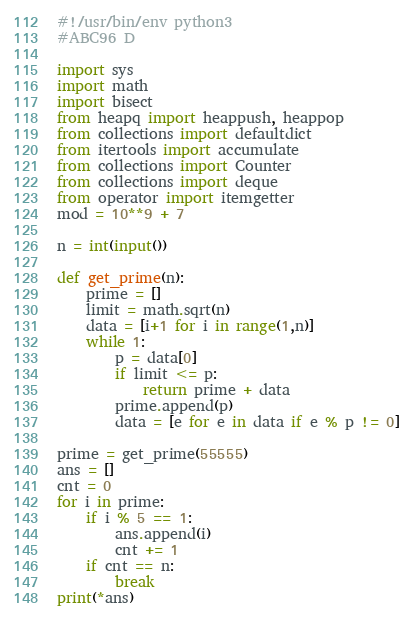Convert code to text. <code><loc_0><loc_0><loc_500><loc_500><_Python_>#!/usr/bin/env python3
#ABC96 D

import sys
import math
import bisect
from heapq import heappush, heappop
from collections import defaultdict
from itertools import accumulate
from collections import Counter
from collections import deque
from operator import itemgetter
mod = 10**9 + 7

n = int(input())

def get_prime(n):
    prime = []
    limit = math.sqrt(n)
    data = [i+1 for i in range(1,n)]
    while 1:
        p = data[0]
        if limit <= p:
            return prime + data
        prime.append(p)
        data = [e for e in data if e % p != 0]

prime = get_prime(55555)
ans = []
cnt = 0
for i in prime:
    if i % 5 == 1:
        ans.append(i)
        cnt += 1
    if cnt == n:
        break
print(*ans)
</code> 